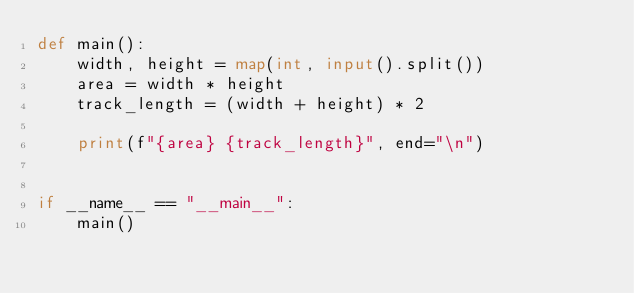Convert code to text. <code><loc_0><loc_0><loc_500><loc_500><_Python_>def main():
    width, height = map(int, input().split())
    area = width * height
    track_length = (width + height) * 2

    print(f"{area} {track_length}", end="\n")


if __name__ == "__main__":
    main()

</code> 